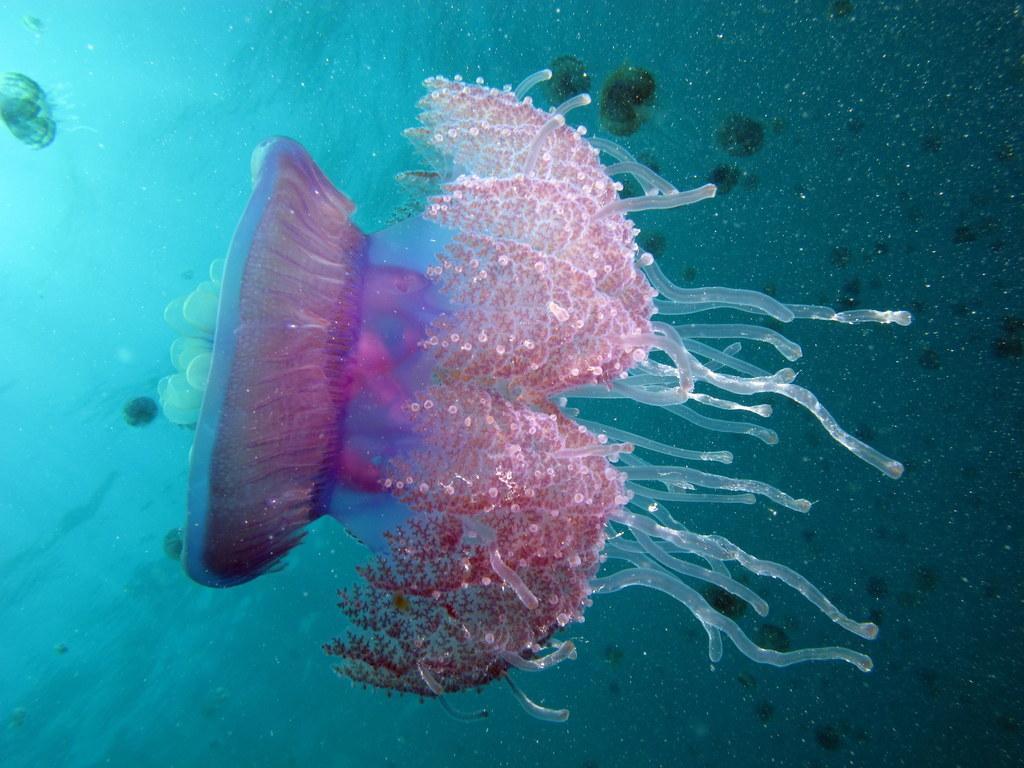Please provide a concise description of this image. In this picture there are jellyfishes in the water. 